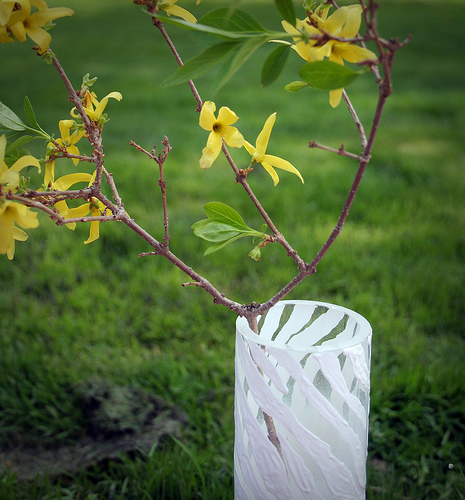<image>
Is the flowers in the vase? Yes. The flowers is contained within or inside the vase, showing a containment relationship. Where is the sprig in relation to the glass? Is it in the glass? Yes. The sprig is contained within or inside the glass, showing a containment relationship. Where is the plant in relation to the pot? Is it behind the pot? No. The plant is not behind the pot. From this viewpoint, the plant appears to be positioned elsewhere in the scene. 